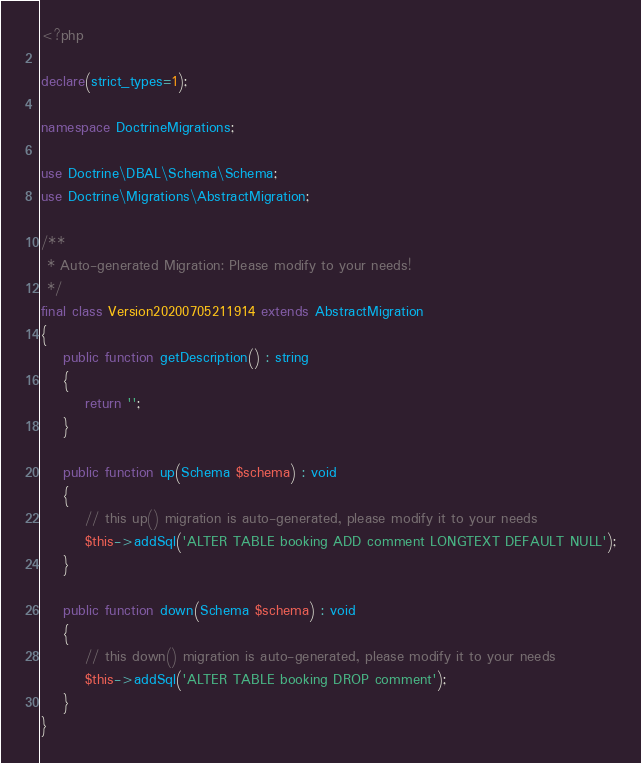Convert code to text. <code><loc_0><loc_0><loc_500><loc_500><_PHP_><?php

declare(strict_types=1);

namespace DoctrineMigrations;

use Doctrine\DBAL\Schema\Schema;
use Doctrine\Migrations\AbstractMigration;

/**
 * Auto-generated Migration: Please modify to your needs!
 */
final class Version20200705211914 extends AbstractMigration
{
    public function getDescription() : string
    {
        return '';
    }

    public function up(Schema $schema) : void
    {
        // this up() migration is auto-generated, please modify it to your needs
        $this->addSql('ALTER TABLE booking ADD comment LONGTEXT DEFAULT NULL');
    }

    public function down(Schema $schema) : void
    {
        // this down() migration is auto-generated, please modify it to your needs
        $this->addSql('ALTER TABLE booking DROP comment');
    }
}
</code> 